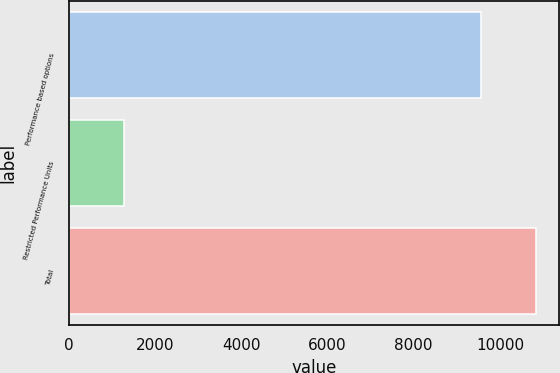Convert chart. <chart><loc_0><loc_0><loc_500><loc_500><bar_chart><fcel>Performance based options<fcel>Restricted Performance Units<fcel>Total<nl><fcel>9549<fcel>1285<fcel>10834<nl></chart> 